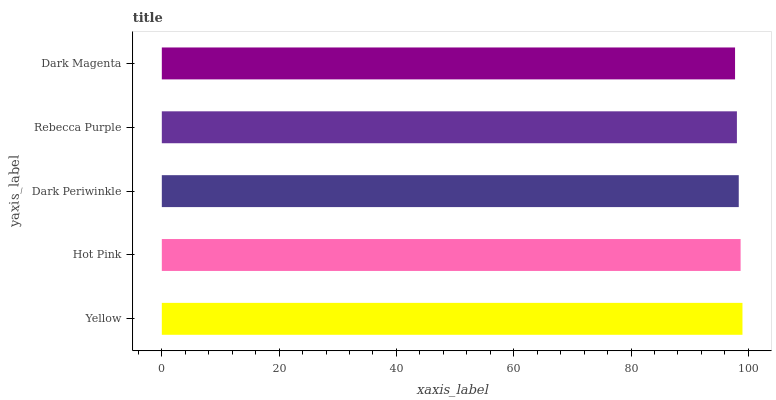Is Dark Magenta the minimum?
Answer yes or no. Yes. Is Yellow the maximum?
Answer yes or no. Yes. Is Hot Pink the minimum?
Answer yes or no. No. Is Hot Pink the maximum?
Answer yes or no. No. Is Yellow greater than Hot Pink?
Answer yes or no. Yes. Is Hot Pink less than Yellow?
Answer yes or no. Yes. Is Hot Pink greater than Yellow?
Answer yes or no. No. Is Yellow less than Hot Pink?
Answer yes or no. No. Is Dark Periwinkle the high median?
Answer yes or no. Yes. Is Dark Periwinkle the low median?
Answer yes or no. Yes. Is Dark Magenta the high median?
Answer yes or no. No. Is Dark Magenta the low median?
Answer yes or no. No. 